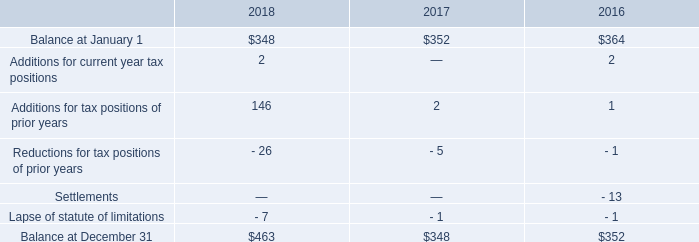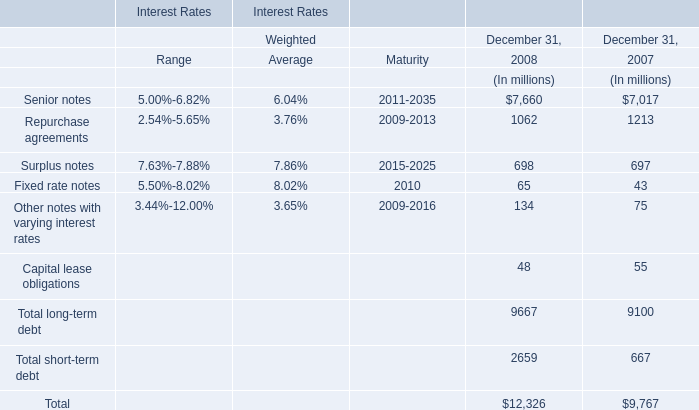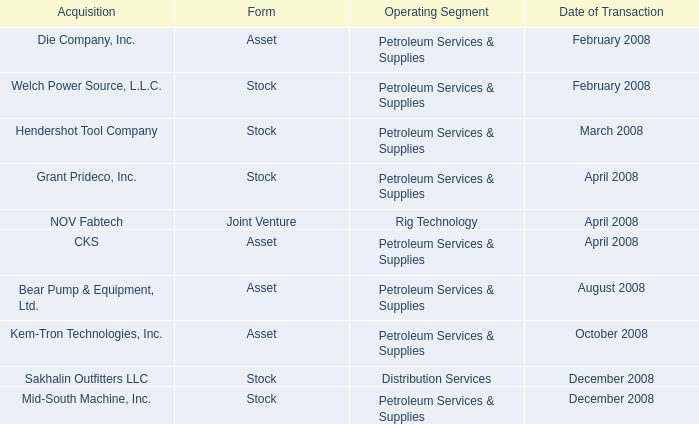what was the percentage change of unrecognized tax benefits at year end between 2016 and 2017? 
Computations: ((348 - 352) / 352)
Answer: -0.01136. 